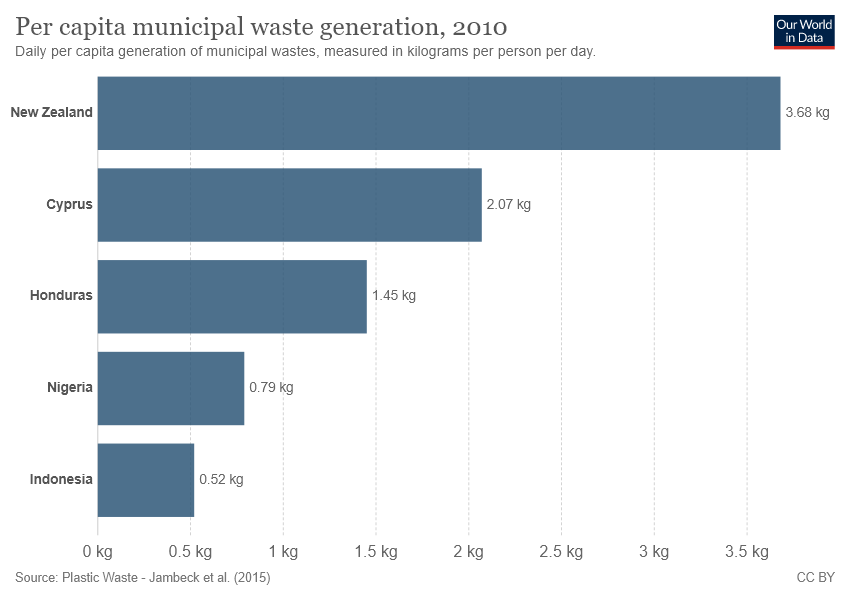Indicate a few pertinent items in this graphic. According to the provided information, the country with the highest per capita municipal waste generation is New Zealand, with a value of 3.68. The Per capita municipal waste generation between New Zealand and Cyprus is higher than that of Honduras, and it exceeds the value of Honduras. 